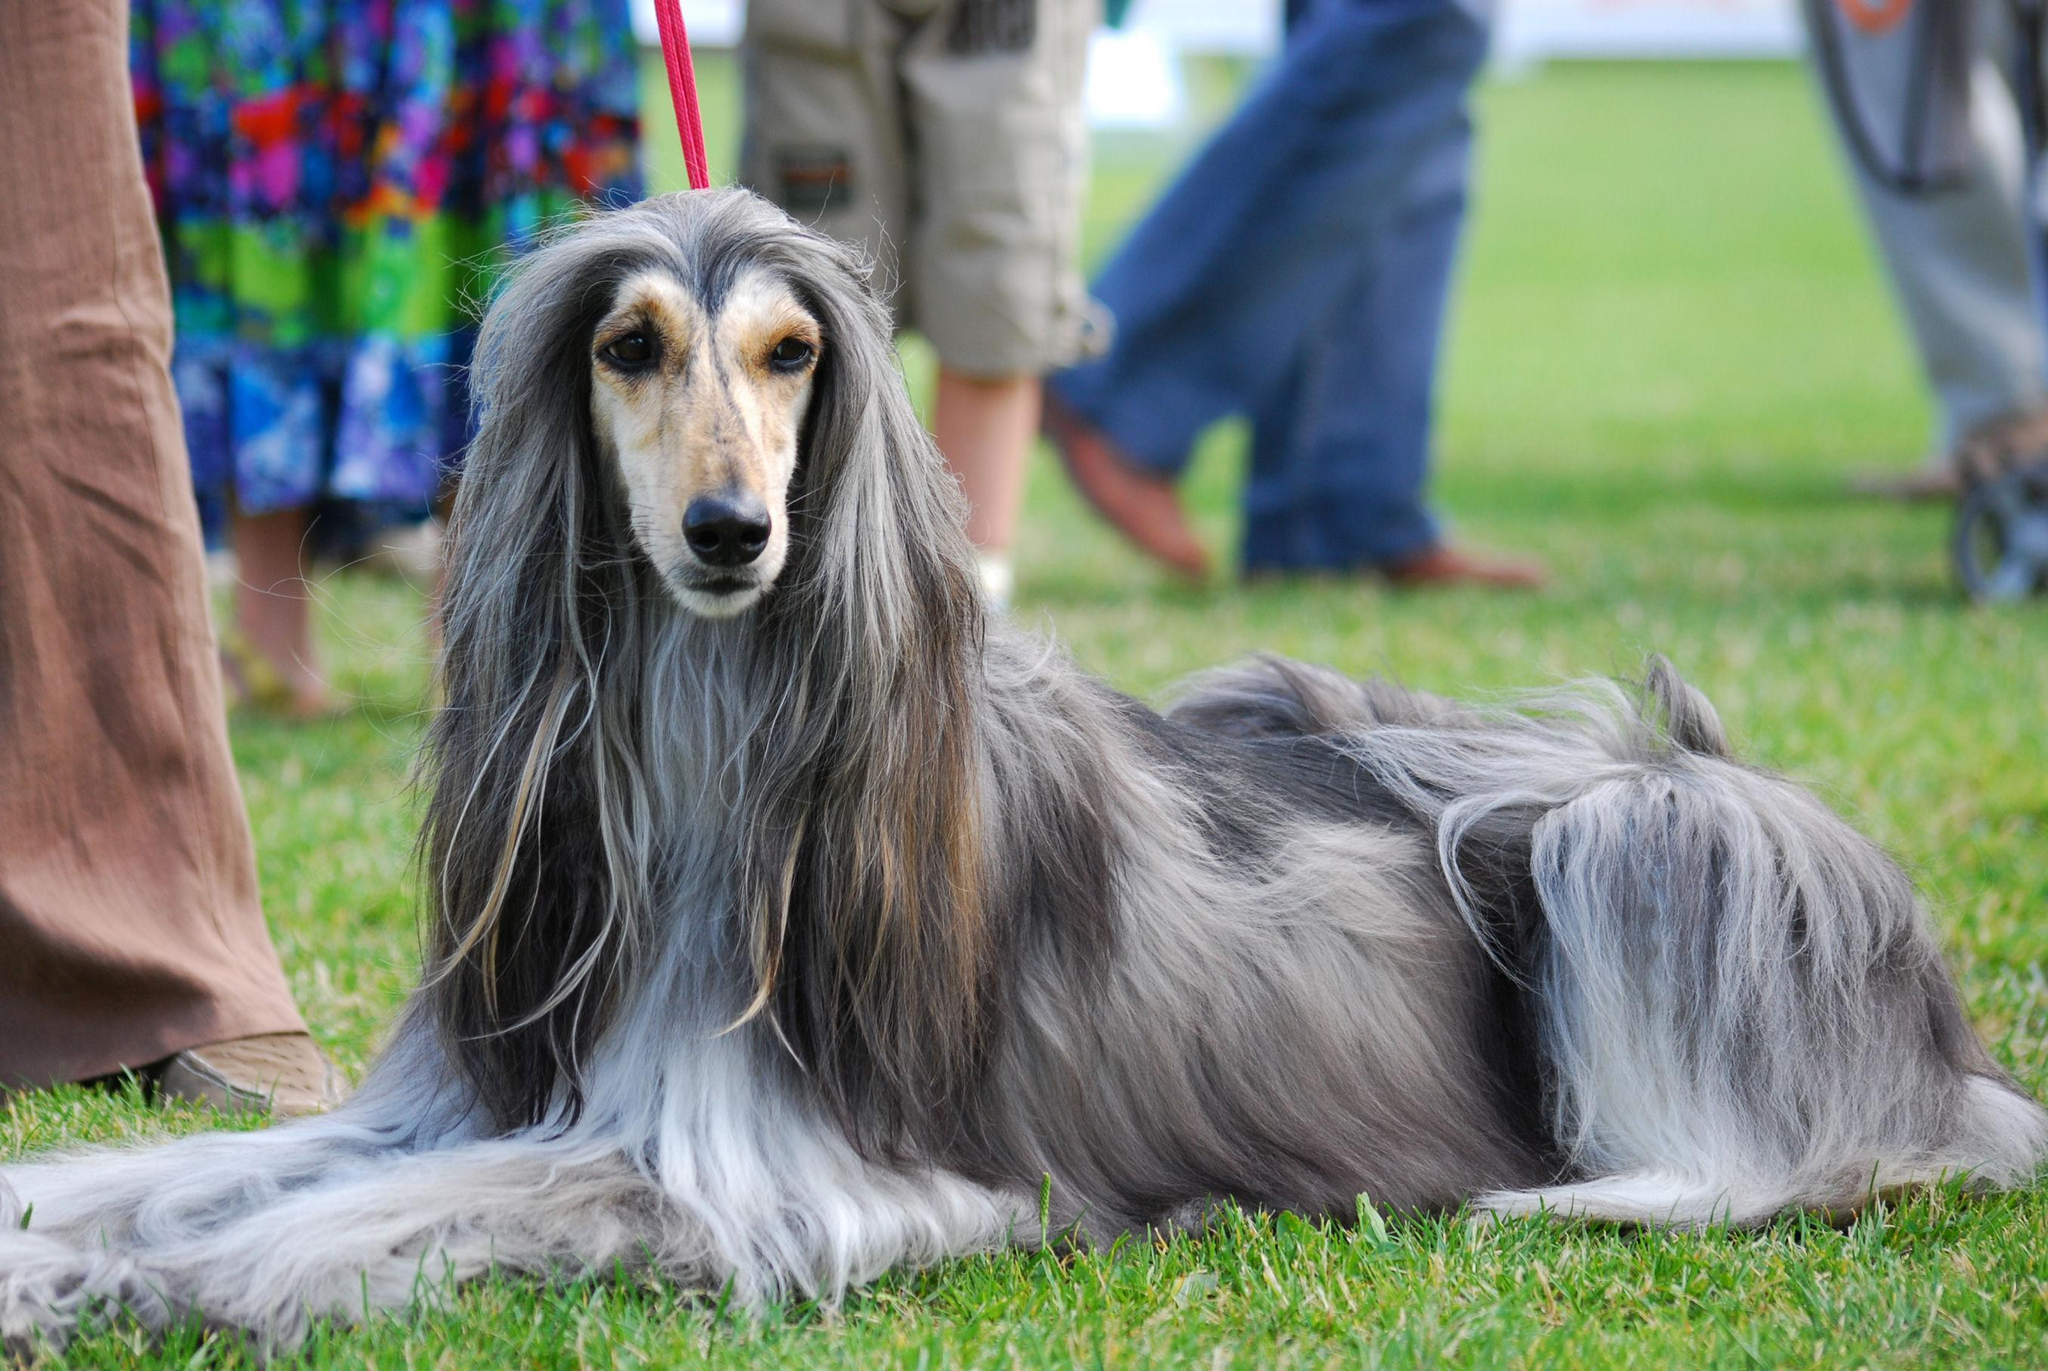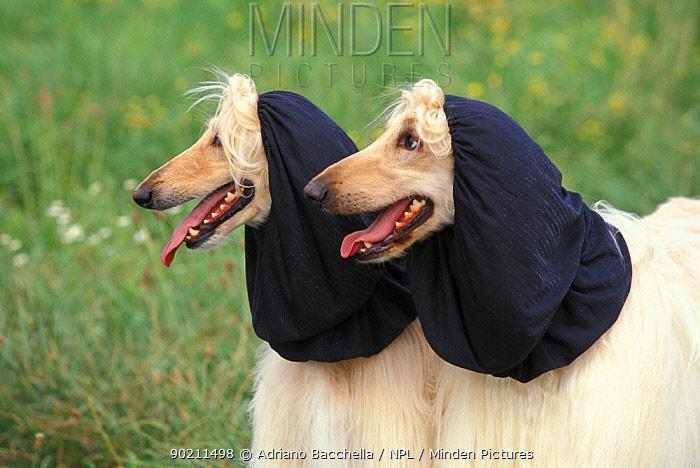The first image is the image on the left, the second image is the image on the right. For the images shown, is this caption "One of the images contains two of the afghan hounds." true? Answer yes or no. Yes. The first image is the image on the left, the second image is the image on the right. For the images displayed, is the sentence "There are two Afghan Hounds outside in the right image." factually correct? Answer yes or no. Yes. 